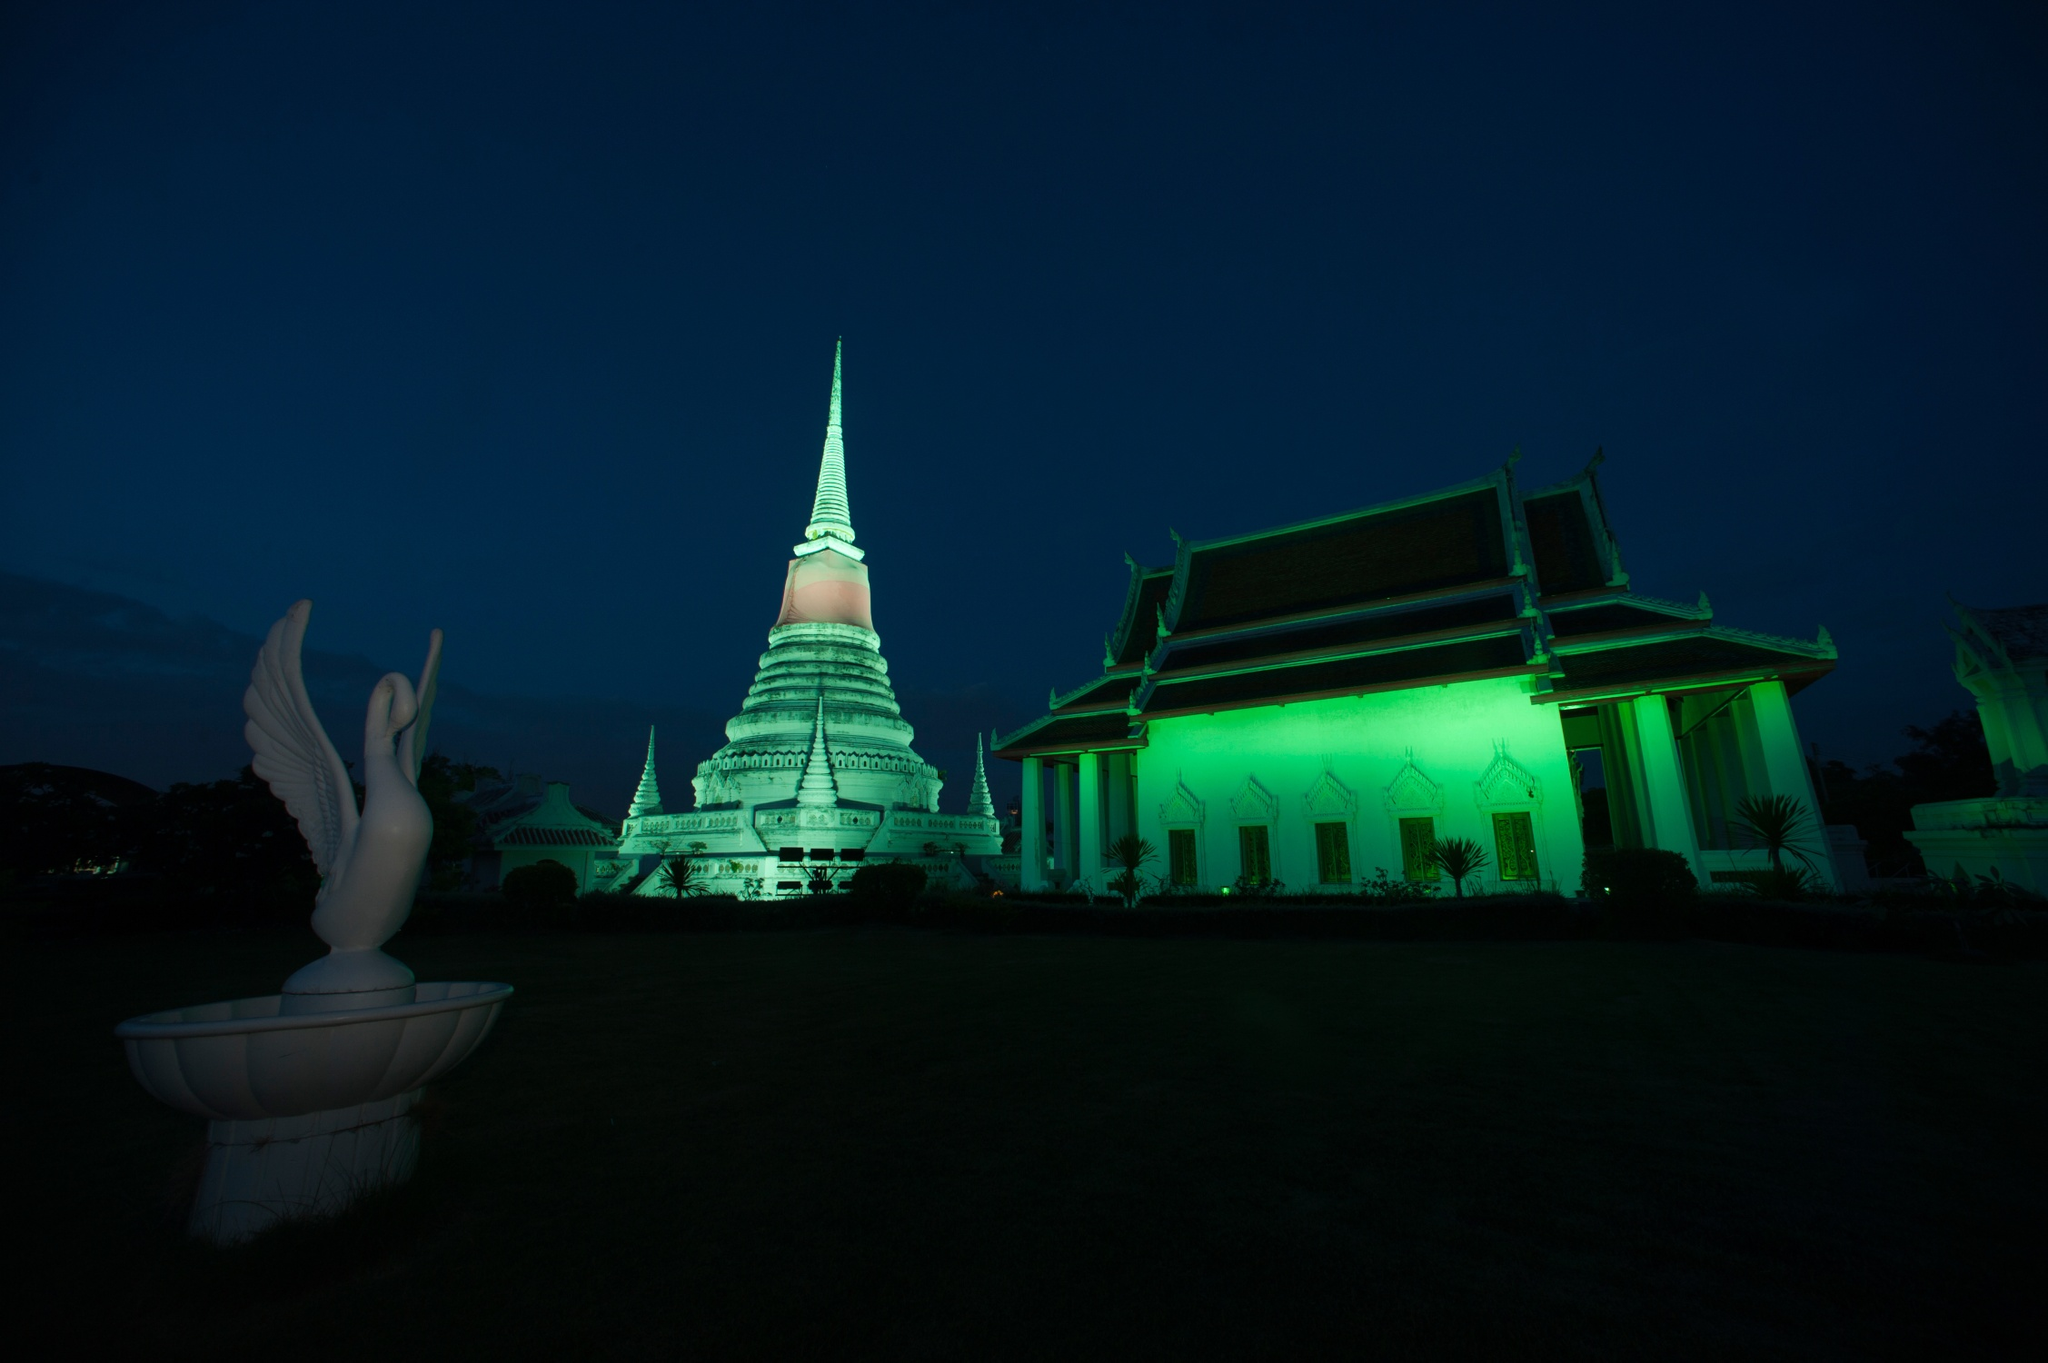What could be the story behind the bird statue in the temple grounds? The bird statue could symbolize various elements of Thai culture or religious beliefs. In Thai mythology, birds often represent freedom, spirituality, and messengers of the divine. This particular statue, with its wings spread wide, might symbolize spiritual ascension or the presence of a divine messenger guarding the temple. 